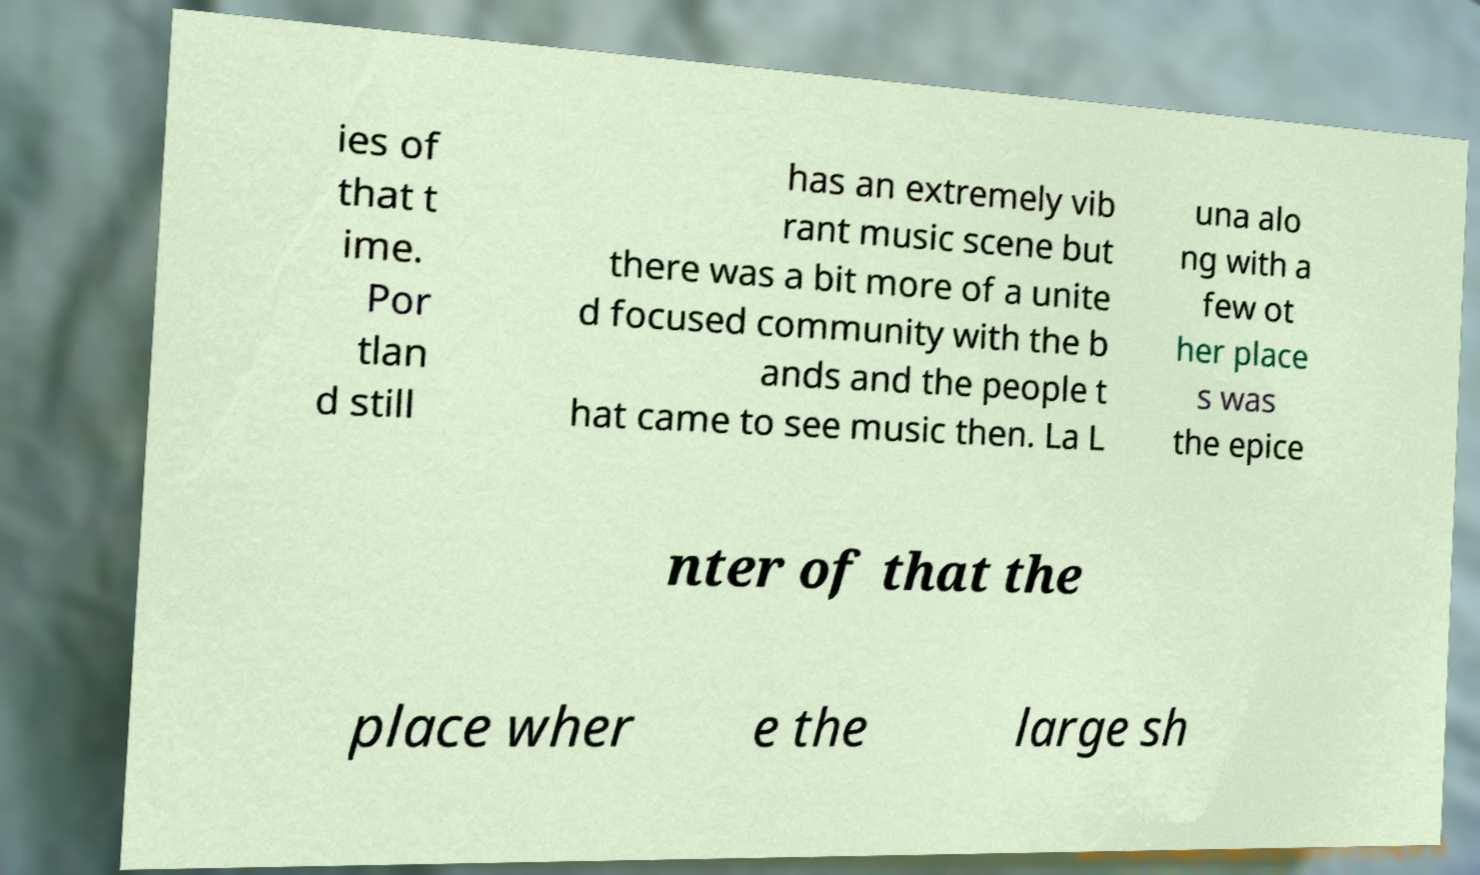Could you extract and type out the text from this image? ies of that t ime. Por tlan d still has an extremely vib rant music scene but there was a bit more of a unite d focused community with the b ands and the people t hat came to see music then. La L una alo ng with a few ot her place s was the epice nter of that the place wher e the large sh 